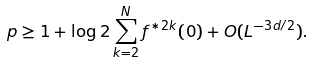Convert formula to latex. <formula><loc_0><loc_0><loc_500><loc_500>p \geq 1 + \log 2 \sum _ { k = 2 } ^ { N } f ^ { \ast 2 k } ( 0 ) + O ( L ^ { - 3 d / 2 } ) .</formula> 